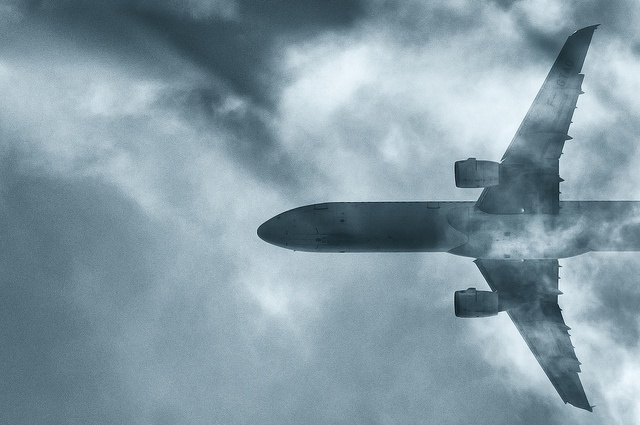Describe the objects in this image and their specific colors. I can see a airplane in gray, blue, and darkgray tones in this image. 